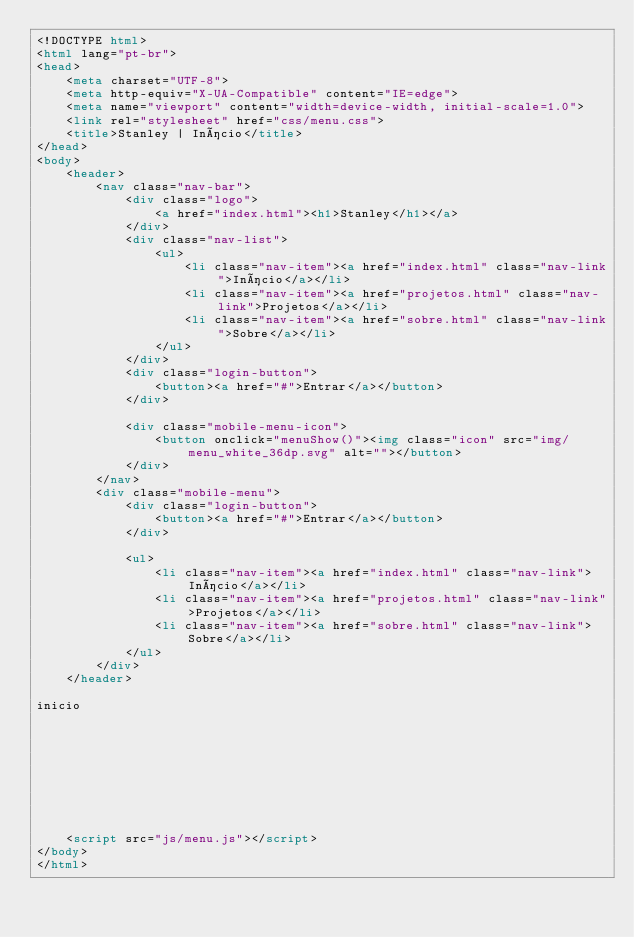<code> <loc_0><loc_0><loc_500><loc_500><_HTML_><!DOCTYPE html>
<html lang="pt-br">
<head>
    <meta charset="UTF-8">
    <meta http-equiv="X-UA-Compatible" content="IE=edge">
    <meta name="viewport" content="width=device-width, initial-scale=1.0">
    <link rel="stylesheet" href="css/menu.css">
    <title>Stanley | Início</title>
</head>
<body>
    <header>
        <nav class="nav-bar">
            <div class="logo">
                <a href="index.html"><h1>Stanley</h1></a>                
            </div>
            <div class="nav-list">
                <ul>
                    <li class="nav-item"><a href="index.html" class="nav-link">Início</a></li>
                    <li class="nav-item"><a href="projetos.html" class="nav-link">Projetos</a></li>
                    <li class="nav-item"><a href="sobre.html" class="nav-link">Sobre</a></li>
                </ul>
            </div>
            <div class="login-button">
                <button><a href="#">Entrar</a></button>
            </div>

            <div class="mobile-menu-icon">
                <button onclick="menuShow()"><img class="icon" src="img/menu_white_36dp.svg" alt=""></button>
            </div>
        </nav>
        <div class="mobile-menu">
            <div class="login-button">
                <button><a href="#">Entrar</a></button>
            </div>

            <ul>
                <li class="nav-item"><a href="index.html" class="nav-link">Início</a></li>
                <li class="nav-item"><a href="projetos.html" class="nav-link">Projetos</a></li>
                <li class="nav-item"><a href="sobre.html" class="nav-link">Sobre</a></li>
            </ul>            
        </div>
    </header>

inicio









    <script src="js/menu.js"></script>
</body>
</html></code> 